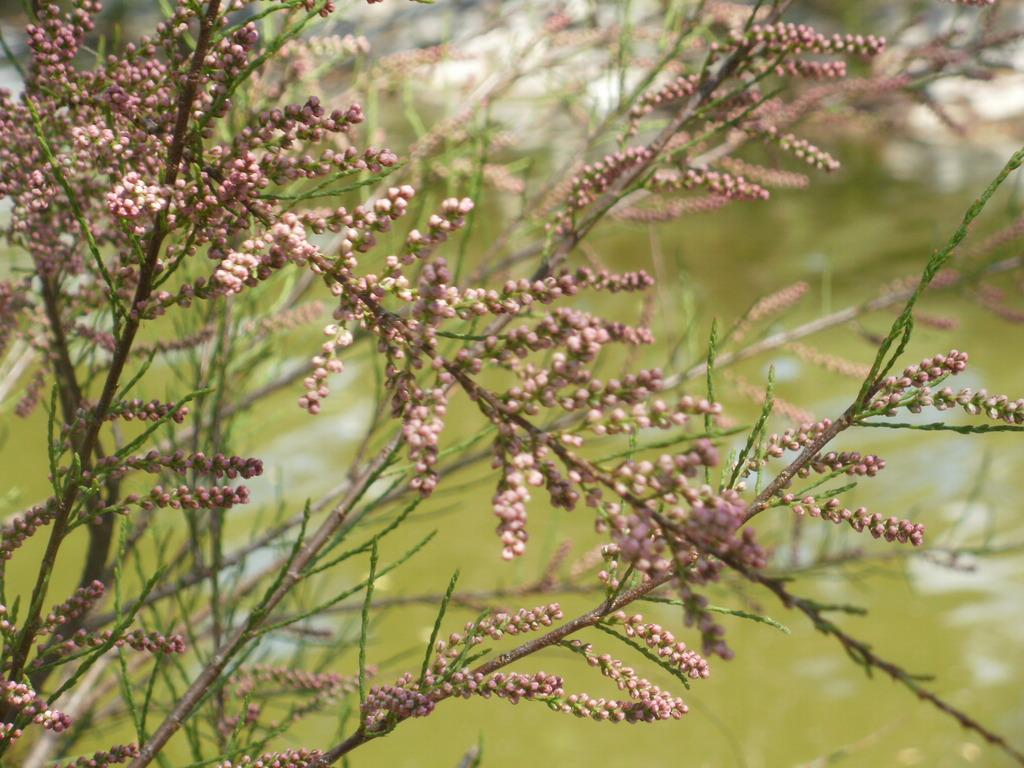What is the main subject of the image? The main subject of the image is a tree. Can you describe the tree in the image? The image is a zoomed-in picture of a tree, so we can see the details of the tree's branches, leaves, and trunk. How many worms can be seen crawling on the sticks in the image? There are no worms or sticks present in the image; it is a zoomed-in picture of a tree. 